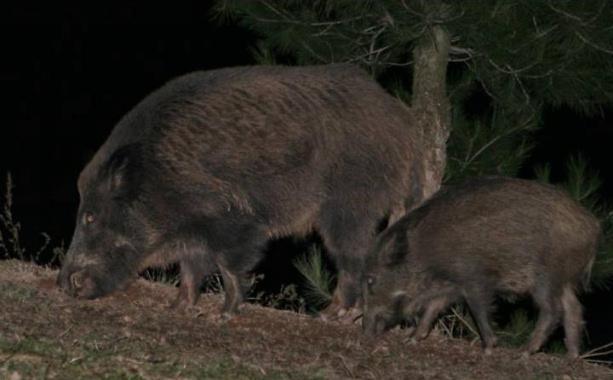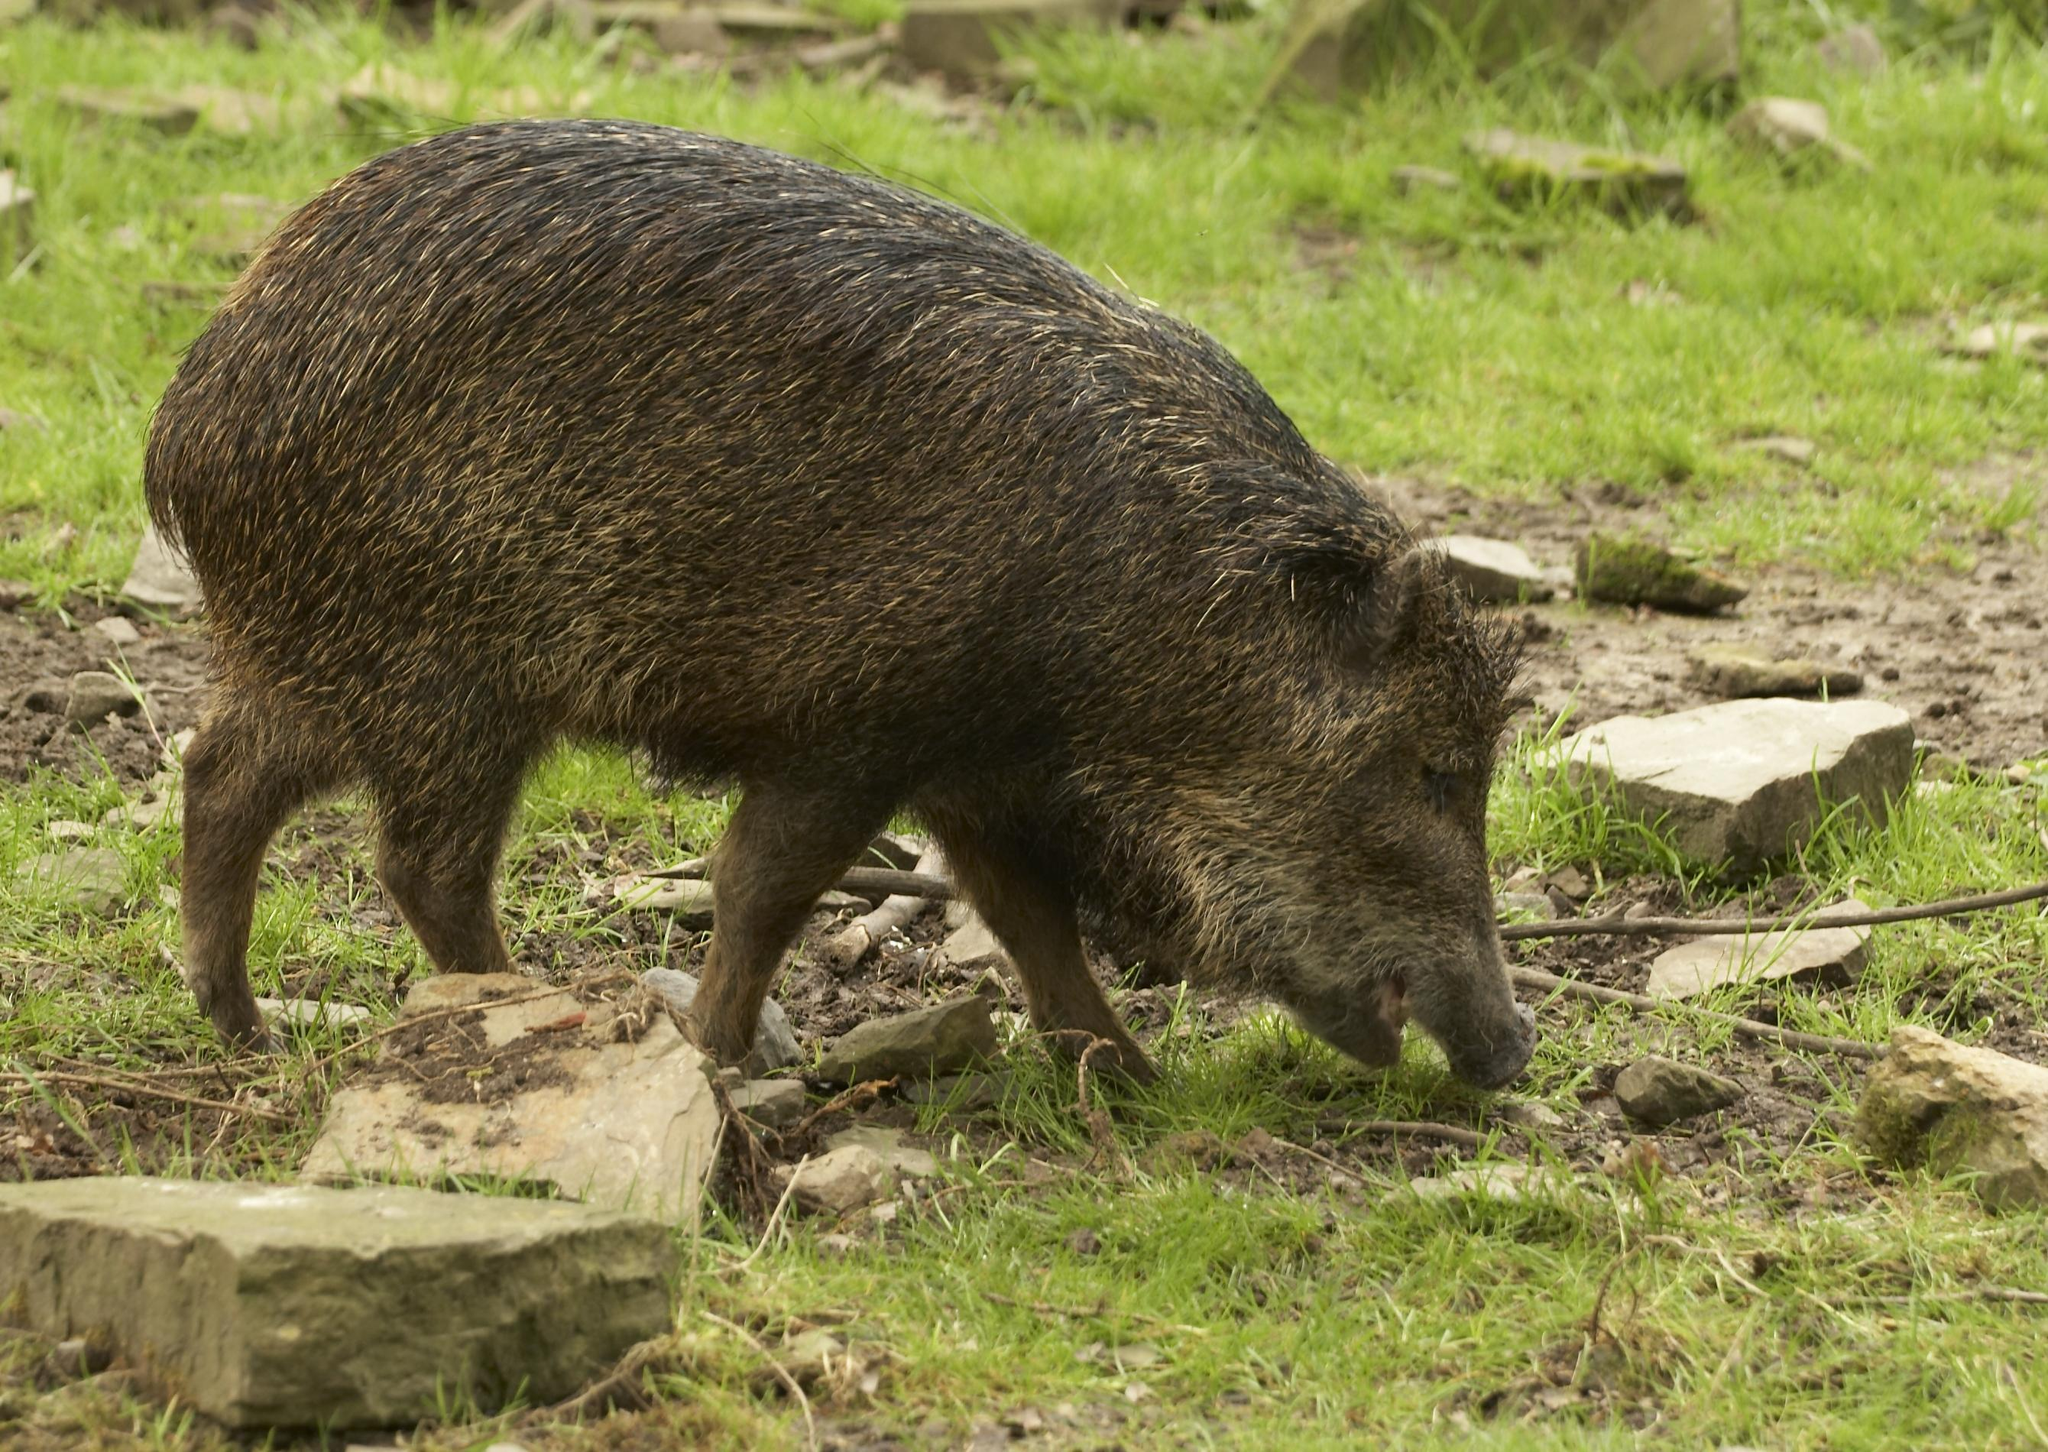The first image is the image on the left, the second image is the image on the right. Considering the images on both sides, is "At least 2 wart hogs are standing in the grass." valid? Answer yes or no. Yes. The first image is the image on the left, the second image is the image on the right. Analyze the images presented: Is the assertion "There are exactly two pigs." valid? Answer yes or no. No. 